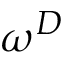Convert formula to latex. <formula><loc_0><loc_0><loc_500><loc_500>\omega ^ { D }</formula> 